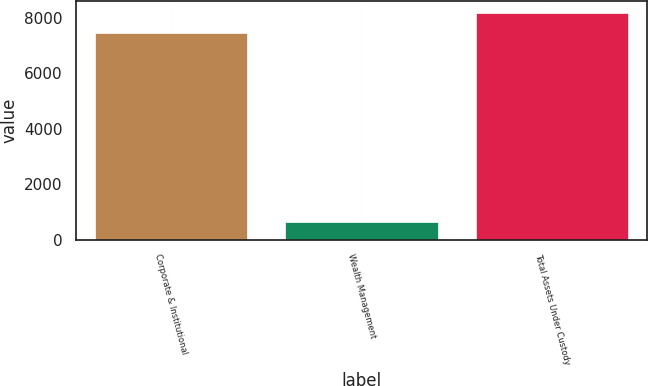<chart> <loc_0><loc_0><loc_500><loc_500><bar_chart><fcel>Corporate & Institutional<fcel>Wealth Management<fcel>Total Assets Under Custody<nl><fcel>7439.1<fcel>645.5<fcel>8183.01<nl></chart> 